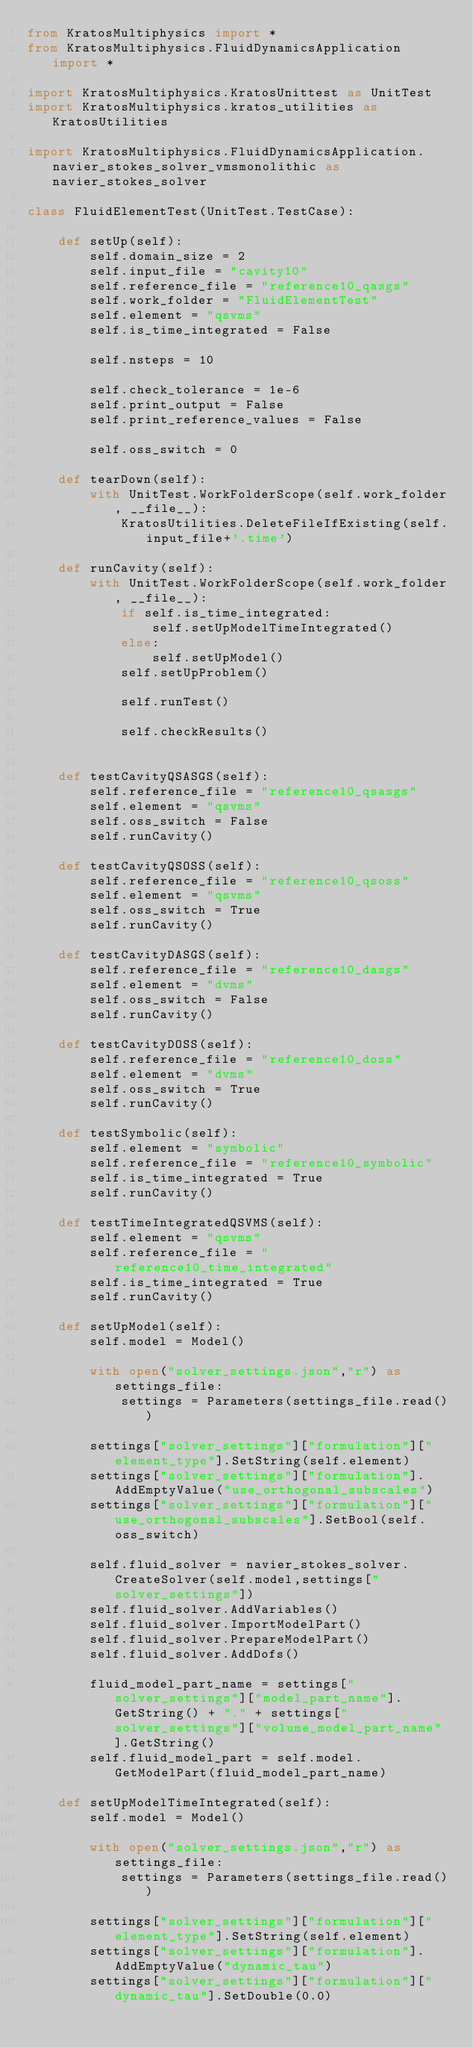Convert code to text. <code><loc_0><loc_0><loc_500><loc_500><_Python_>from KratosMultiphysics import *
from KratosMultiphysics.FluidDynamicsApplication import *

import KratosMultiphysics.KratosUnittest as UnitTest
import KratosMultiphysics.kratos_utilities as KratosUtilities

import KratosMultiphysics.FluidDynamicsApplication.navier_stokes_solver_vmsmonolithic as navier_stokes_solver

class FluidElementTest(UnitTest.TestCase):

    def setUp(self):
        self.domain_size = 2
        self.input_file = "cavity10"
        self.reference_file = "reference10_qasgs"
        self.work_folder = "FluidElementTest"
        self.element = "qsvms"
        self.is_time_integrated = False

        self.nsteps = 10

        self.check_tolerance = 1e-6
        self.print_output = False
        self.print_reference_values = False

        self.oss_switch = 0

    def tearDown(self):
        with UnitTest.WorkFolderScope(self.work_folder, __file__):
            KratosUtilities.DeleteFileIfExisting(self.input_file+'.time')

    def runCavity(self):
        with UnitTest.WorkFolderScope(self.work_folder, __file__):
            if self.is_time_integrated:
                self.setUpModelTimeIntegrated()
            else:
                self.setUpModel()
            self.setUpProblem()

            self.runTest()

            self.checkResults()


    def testCavityQSASGS(self):
        self.reference_file = "reference10_qsasgs"
        self.element = "qsvms"
        self.oss_switch = False
        self.runCavity()

    def testCavityQSOSS(self):
        self.reference_file = "reference10_qsoss"
        self.element = "qsvms"
        self.oss_switch = True
        self.runCavity()

    def testCavityDASGS(self):
        self.reference_file = "reference10_dasgs"
        self.element = "dvms"
        self.oss_switch = False
        self.runCavity()

    def testCavityDOSS(self):
        self.reference_file = "reference10_doss"
        self.element = "dvms"
        self.oss_switch = True
        self.runCavity()

    def testSymbolic(self):
        self.element = "symbolic"
        self.reference_file = "reference10_symbolic"
        self.is_time_integrated = True
        self.runCavity()

    def testTimeIntegratedQSVMS(self):
        self.element = "qsvms"
        self.reference_file = "reference10_time_integrated"
        self.is_time_integrated = True
        self.runCavity()

    def setUpModel(self):
        self.model = Model()

        with open("solver_settings.json","r") as settings_file:
            settings = Parameters(settings_file.read())

        settings["solver_settings"]["formulation"]["element_type"].SetString(self.element)
        settings["solver_settings"]["formulation"].AddEmptyValue("use_orthogonal_subscales")
        settings["solver_settings"]["formulation"]["use_orthogonal_subscales"].SetBool(self.oss_switch)

        self.fluid_solver = navier_stokes_solver.CreateSolver(self.model,settings["solver_settings"])
        self.fluid_solver.AddVariables()
        self.fluid_solver.ImportModelPart()
        self.fluid_solver.PrepareModelPart()
        self.fluid_solver.AddDofs()

        fluid_model_part_name = settings["solver_settings"]["model_part_name"].GetString() + "." + settings["solver_settings"]["volume_model_part_name"].GetString()
        self.fluid_model_part = self.model.GetModelPart(fluid_model_part_name)

    def setUpModelTimeIntegrated(self):
        self.model = Model()

        with open("solver_settings.json","r") as settings_file:
            settings = Parameters(settings_file.read())

        settings["solver_settings"]["formulation"]["element_type"].SetString(self.element)
        settings["solver_settings"]["formulation"].AddEmptyValue("dynamic_tau")
        settings["solver_settings"]["formulation"]["dynamic_tau"].SetDouble(0.0)</code> 